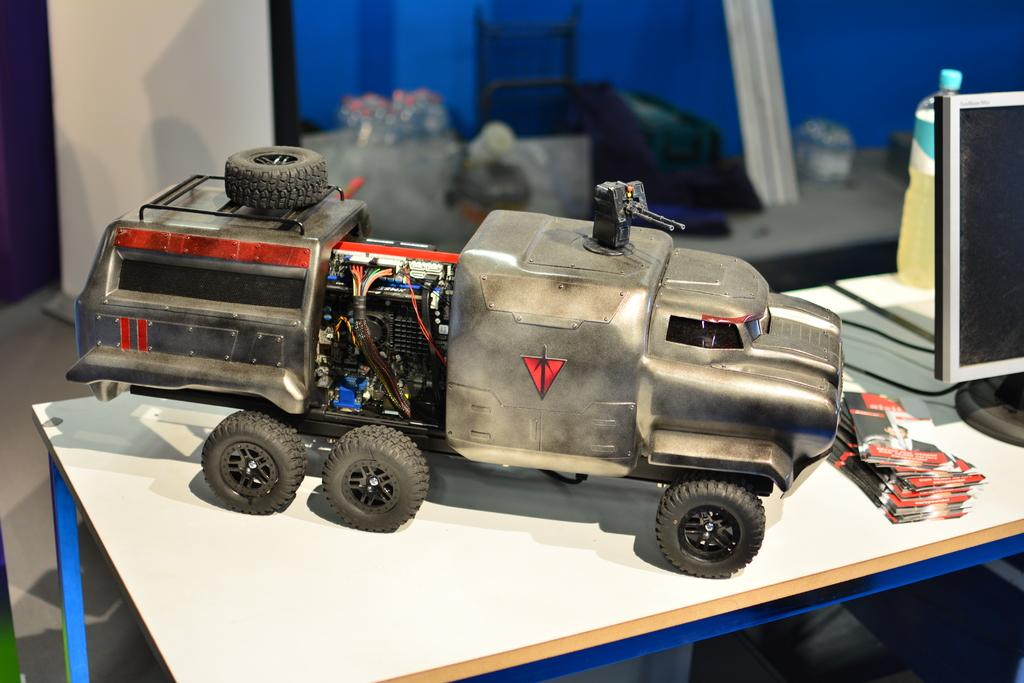What object is placed on the table in the image? There is a toy vehicle on the table. What electronic device is also present on the table? There is a computer on the table. What else can be seen on the table besides the toy vehicle and computer? There are papers and a bottle on the table. Can you describe the background of the image? The background of the image is blurry. How many feet does the servant have in the image? There is no servant present in the image, so it is not possible to determine the number of feet they might have. 